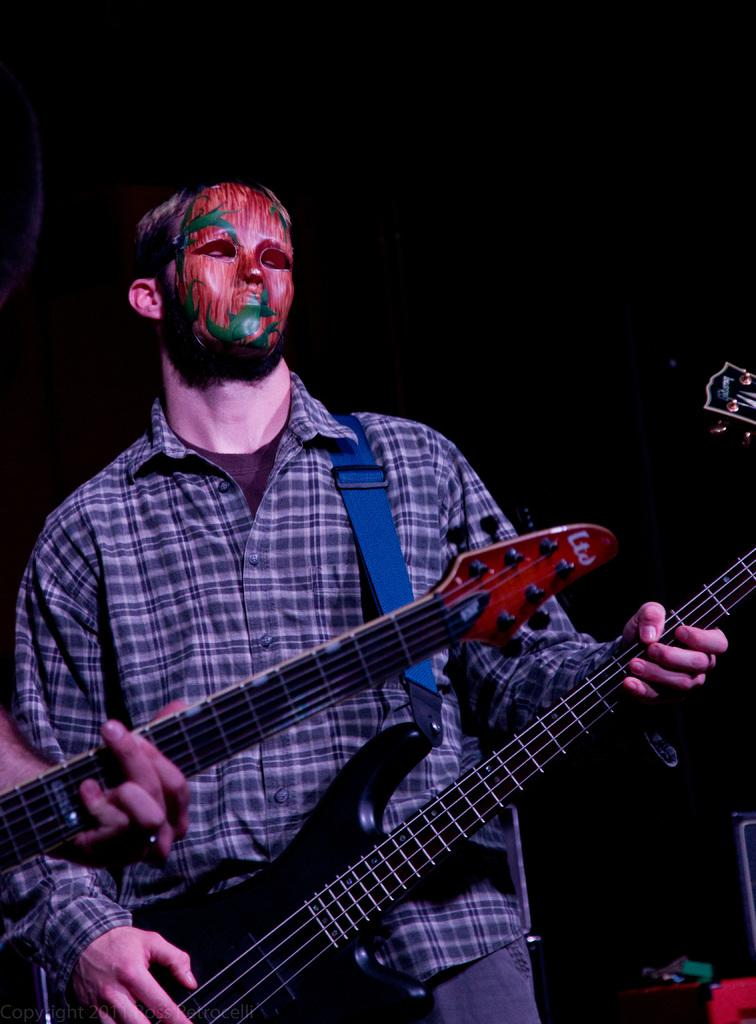What is the man in the image doing? The man is playing a guitar in the image. Can you describe the other person in the image? The other person is also playing a guitar in the image. How many people are playing guitars in the image? There are two people playing guitars in the image. What type of breakfast is being served in the image? There is no breakfast present in the image; it features two people playing guitars. Can you describe the breath of the person playing the guitar? There is no information about the person's breath in the image, as it focuses on their actions and not their physical state. 